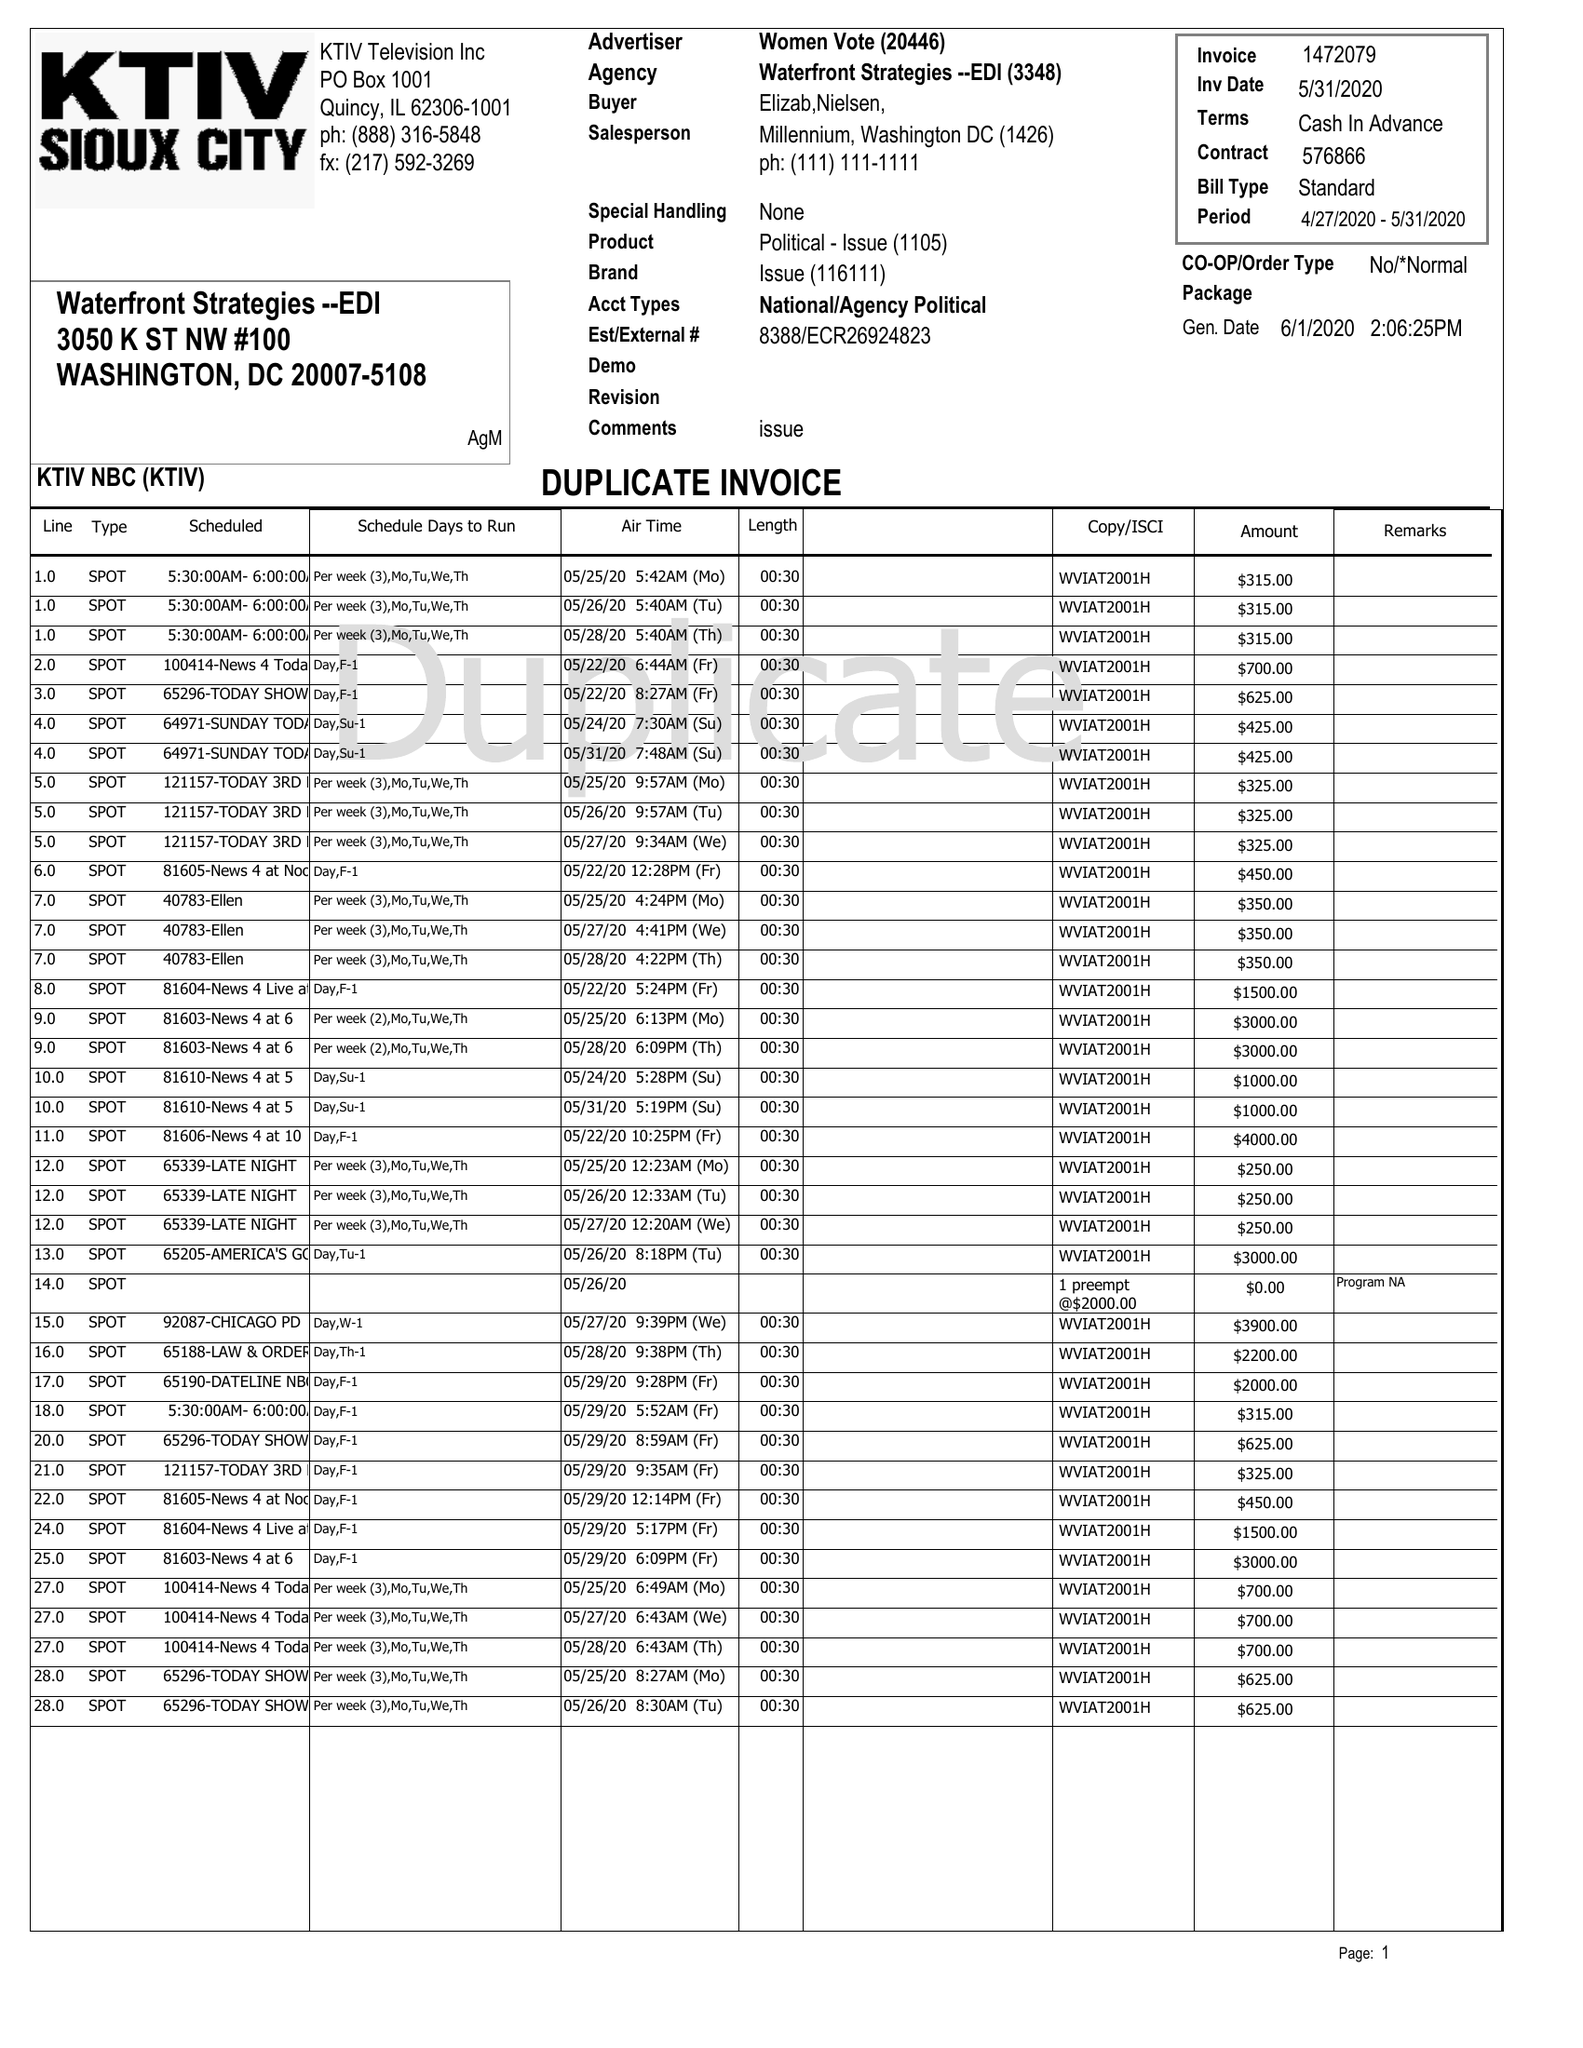What is the value for the advertiser?
Answer the question using a single word or phrase. WOMEN VOTE 